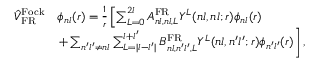Convert formula to latex. <formula><loc_0><loc_0><loc_500><loc_500>\begin{array} { r l } { \hat { V } _ { F R } ^ { F o c k } } & { \phi _ { n l } ( r ) = \frac { 1 } { r } \left [ \sum _ { L = 0 } ^ { 2 l } A _ { n l , n l , L } ^ { F R } Y ^ { L } ( n l , n l ; r ) \phi _ { n l } ( r ) } \\ & { + \sum _ { n ^ { \prime } l ^ { \prime } \neq n l } \sum _ { L = | l - l ^ { \prime } | } ^ { l + l ^ { \prime } } B _ { n l , n ^ { \prime } l ^ { \prime } , L } ^ { F R } Y ^ { L } ( n l , n ^ { \prime } l ^ { \prime } ; r ) \phi _ { n ^ { \prime } l ^ { \prime } } ( r ) \right ] , } \end{array}</formula> 